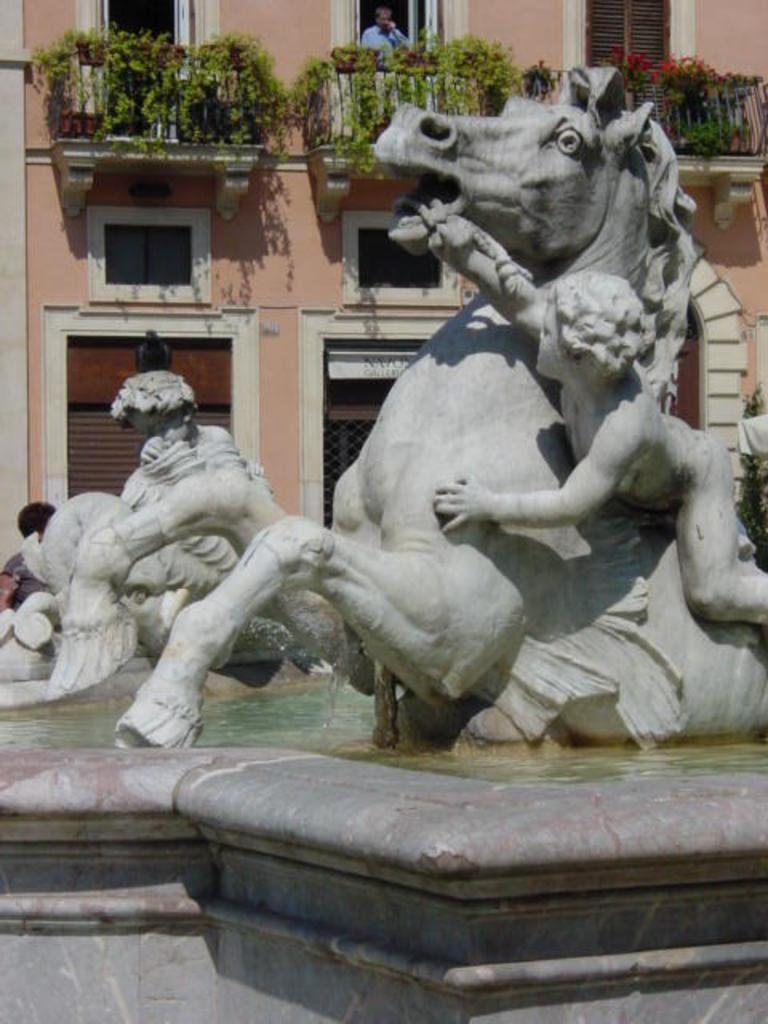What type of objects can be seen in the image? There are statues in the image. What is the statues standing on? There is a pedestal in the image. What is the setting of the image? There is water visible in the image, and there is a building in the image. What type of vegetation is present in the image? Creeper plants are present in the image. Can you describe the person in the image? There is a person standing on the floor in the image. What architectural features can be seen in the image? Windows, railings, and doors are present in the image. What type of insurance is the person in the image discussing with the creeper plants? There is no indication in the image that the person is discussing insurance or interacting with the creeper plants. How much blood can be seen on the railings in the image? There is no blood visible in the image; the railings are clean and unstained. 